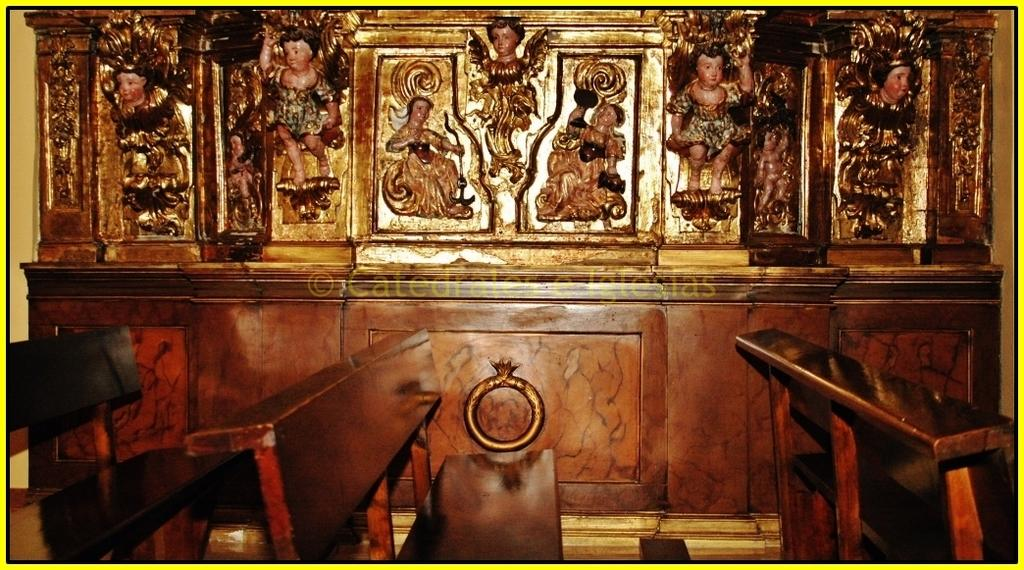What type of artwork can be seen on the wall in the background of the image? There are sculptures on the wall in the background of the image. What type of seating is available at the bottom of the image? There are benches at the bottom of the image. How many goldfish are swimming in the water near the benches in the image? There are no goldfish or water present in the image; it features sculptures on the wall and benches at the bottom. What type of account is being discussed in the image? There is no discussion of an account in the image; it focuses on sculptures and benches. 